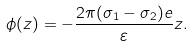Convert formula to latex. <formula><loc_0><loc_0><loc_500><loc_500>\phi ( z ) = - \frac { 2 \pi ( \sigma _ { 1 } - \sigma _ { 2 } ) e } { \varepsilon } z .</formula> 